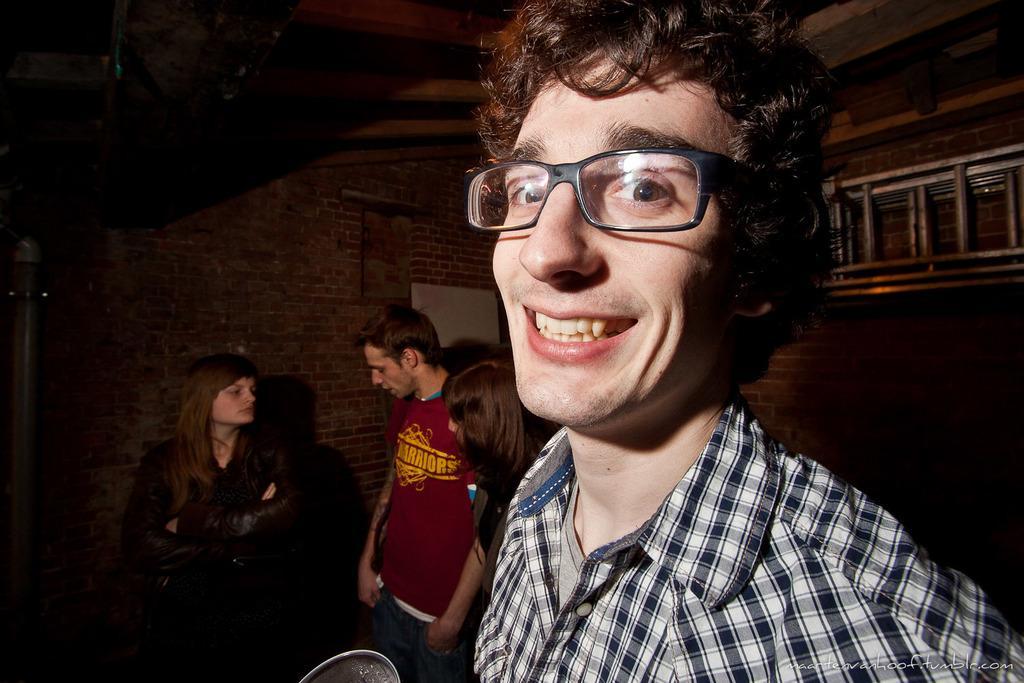Please provide a concise description of this image. In this image we can see few people. Behind the persons we can see a wall and a ladder. At the top we can see the roof. 